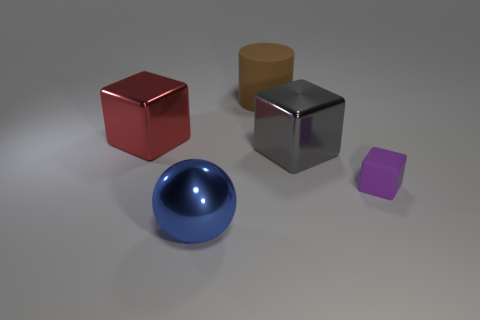How many big objects are either red metal blocks or gray rubber balls?
Provide a short and direct response. 1. Does the blue object left of the tiny purple cube have the same material as the big thing that is on the right side of the large rubber cylinder?
Your answer should be very brief. Yes. Are any large purple metal cylinders visible?
Your answer should be compact. No. Is the number of blocks that are behind the gray shiny cube greater than the number of cylinders to the right of the big brown rubber object?
Give a very brief answer. Yes. What is the material of the purple thing that is the same shape as the big red object?
Provide a short and direct response. Rubber. Are there any other things that are the same size as the purple object?
Your answer should be very brief. No. There is a purple thing; what shape is it?
Ensure brevity in your answer.  Cube. Is the number of small purple rubber blocks that are to the right of the large matte thing greater than the number of tiny cyan metallic blocks?
Make the answer very short. Yes. There is a metal object on the left side of the ball; what is its shape?
Your response must be concise. Cube. What number of other objects are there of the same shape as the large gray metallic object?
Make the answer very short. 2. 